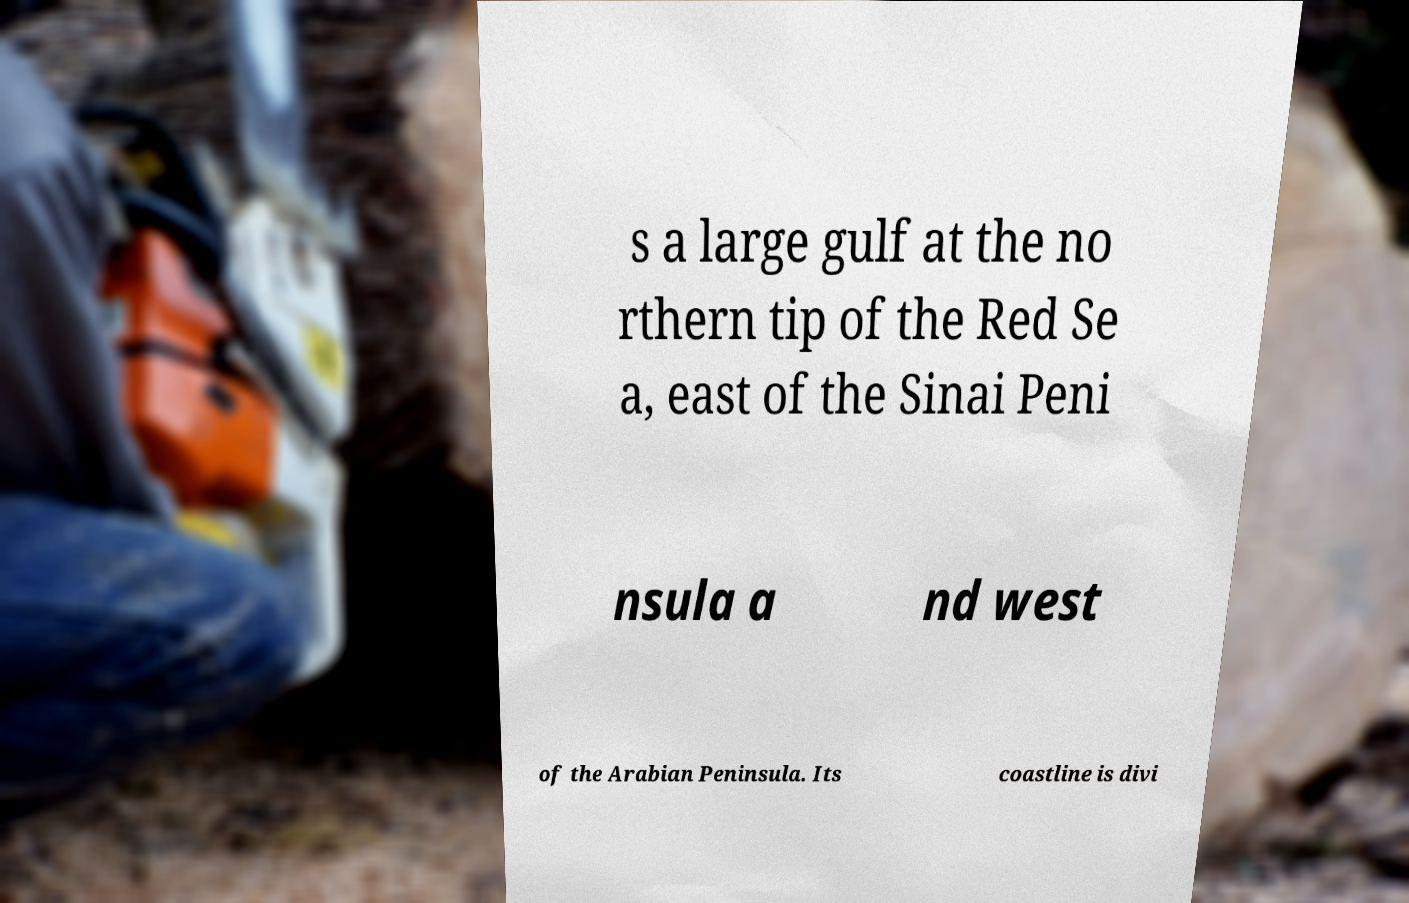I need the written content from this picture converted into text. Can you do that? s a large gulf at the no rthern tip of the Red Se a, east of the Sinai Peni nsula a nd west of the Arabian Peninsula. Its coastline is divi 